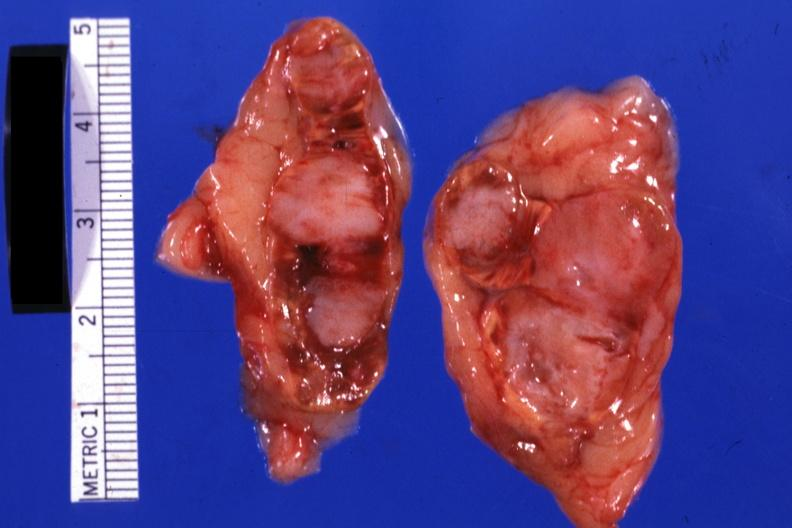s adrenal present?
Answer the question using a single word or phrase. Yes 